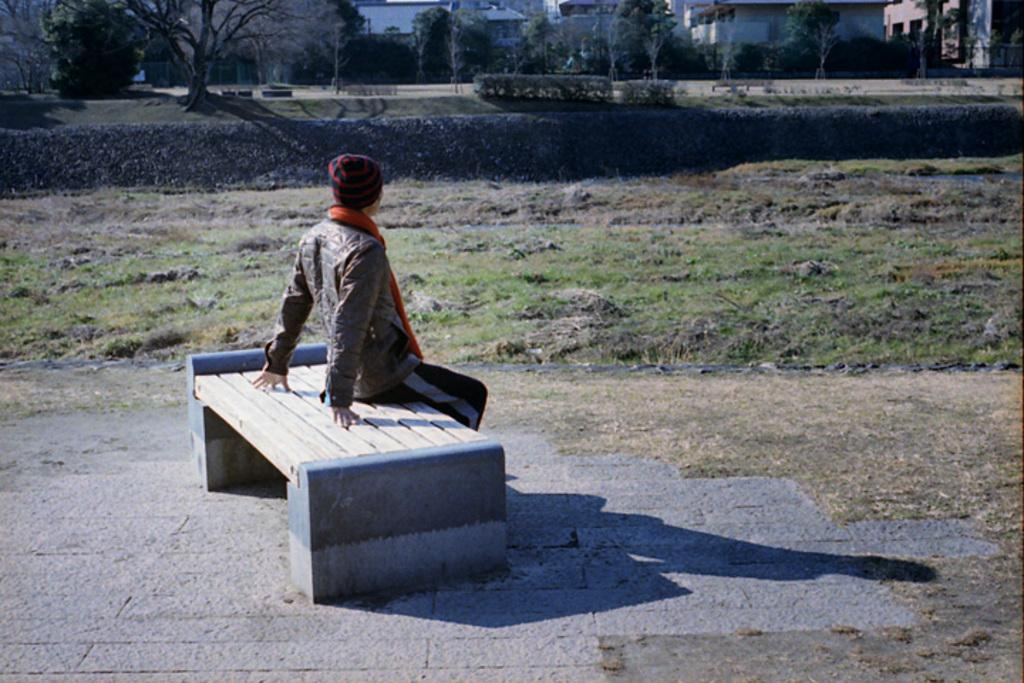What is the main subject of the image? There is a person in the image. What type of clothing is the person wearing? The person is wearing a jacket, a scarf, and a cap. What is the person doing in the image? The person is sitting on a bench. Can you describe the bench in the image? The bench is on the floor. What can be seen in the background of the image? There are houses, trees, a path, and a wall in the background of the image. What type of carriage can be seen in the image? There is no carriage present in the image. What station is the person waiting at in the image? There is no station present in the image. 